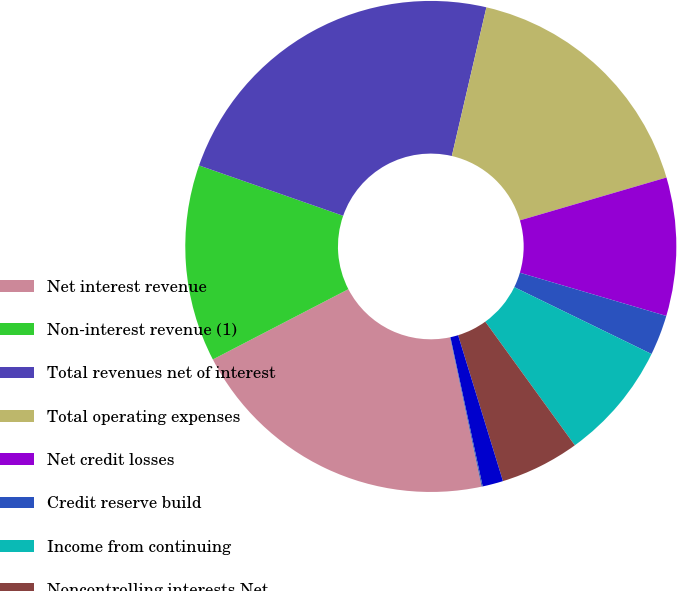Convert chart. <chart><loc_0><loc_0><loc_500><loc_500><pie_chart><fcel>Net interest revenue<fcel>Non-interest revenue (1)<fcel>Total revenues net of interest<fcel>Total operating expenses<fcel>Net credit losses<fcel>Credit reserve build<fcel>Income from continuing<fcel>Noncontrolling interests Net<fcel>Average assets<fcel>Average deposits<nl><fcel>20.71%<fcel>12.97%<fcel>23.29%<fcel>16.84%<fcel>9.1%<fcel>2.65%<fcel>7.81%<fcel>5.23%<fcel>1.36%<fcel>0.07%<nl></chart> 